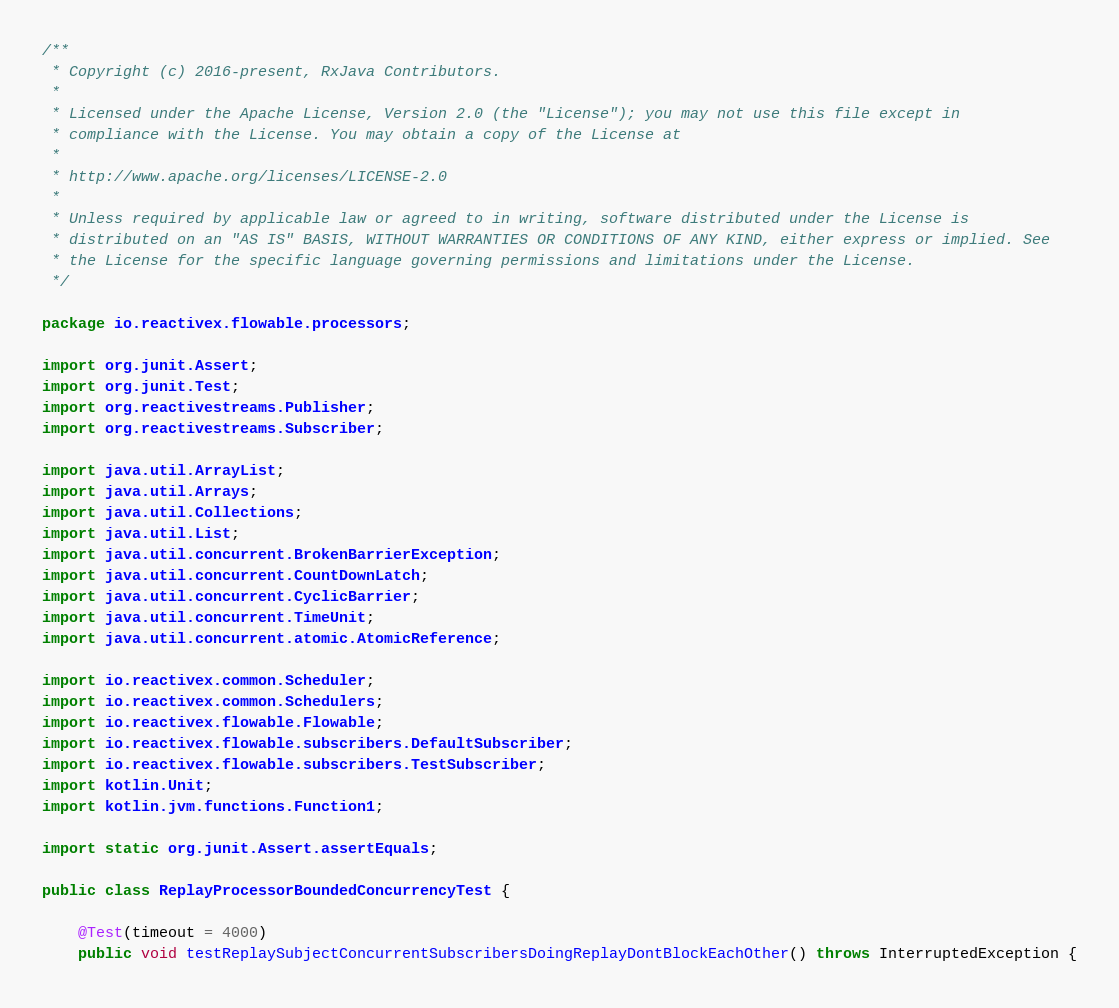Convert code to text. <code><loc_0><loc_0><loc_500><loc_500><_Java_>/**
 * Copyright (c) 2016-present, RxJava Contributors.
 *
 * Licensed under the Apache License, Version 2.0 (the "License"); you may not use this file except in
 * compliance with the License. You may obtain a copy of the License at
 *
 * http://www.apache.org/licenses/LICENSE-2.0
 *
 * Unless required by applicable law or agreed to in writing, software distributed under the License is
 * distributed on an "AS IS" BASIS, WITHOUT WARRANTIES OR CONDITIONS OF ANY KIND, either express or implied. See
 * the License for the specific language governing permissions and limitations under the License.
 */

package io.reactivex.flowable.processors;

import org.junit.Assert;
import org.junit.Test;
import org.reactivestreams.Publisher;
import org.reactivestreams.Subscriber;

import java.util.ArrayList;
import java.util.Arrays;
import java.util.Collections;
import java.util.List;
import java.util.concurrent.BrokenBarrierException;
import java.util.concurrent.CountDownLatch;
import java.util.concurrent.CyclicBarrier;
import java.util.concurrent.TimeUnit;
import java.util.concurrent.atomic.AtomicReference;

import io.reactivex.common.Scheduler;
import io.reactivex.common.Schedulers;
import io.reactivex.flowable.Flowable;
import io.reactivex.flowable.subscribers.DefaultSubscriber;
import io.reactivex.flowable.subscribers.TestSubscriber;
import kotlin.Unit;
import kotlin.jvm.functions.Function1;

import static org.junit.Assert.assertEquals;

public class ReplayProcessorBoundedConcurrencyTest {

    @Test(timeout = 4000)
    public void testReplaySubjectConcurrentSubscribersDoingReplayDontBlockEachOther() throws InterruptedException {</code> 